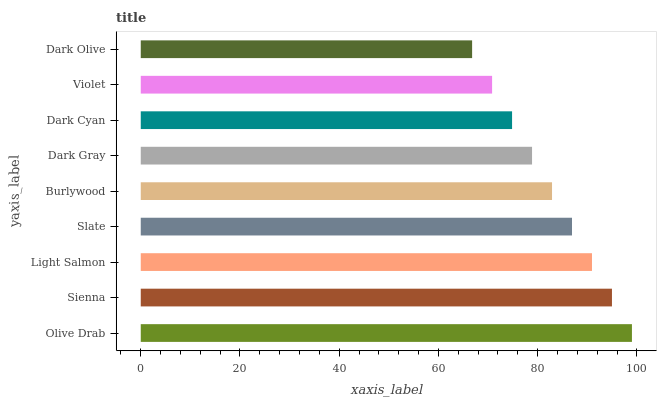Is Dark Olive the minimum?
Answer yes or no. Yes. Is Olive Drab the maximum?
Answer yes or no. Yes. Is Sienna the minimum?
Answer yes or no. No. Is Sienna the maximum?
Answer yes or no. No. Is Olive Drab greater than Sienna?
Answer yes or no. Yes. Is Sienna less than Olive Drab?
Answer yes or no. Yes. Is Sienna greater than Olive Drab?
Answer yes or no. No. Is Olive Drab less than Sienna?
Answer yes or no. No. Is Burlywood the high median?
Answer yes or no. Yes. Is Burlywood the low median?
Answer yes or no. Yes. Is Light Salmon the high median?
Answer yes or no. No. Is Slate the low median?
Answer yes or no. No. 